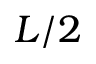Convert formula to latex. <formula><loc_0><loc_0><loc_500><loc_500>L / 2</formula> 